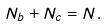Convert formula to latex. <formula><loc_0><loc_0><loc_500><loc_500>N _ { b } + N _ { c } = N .</formula> 